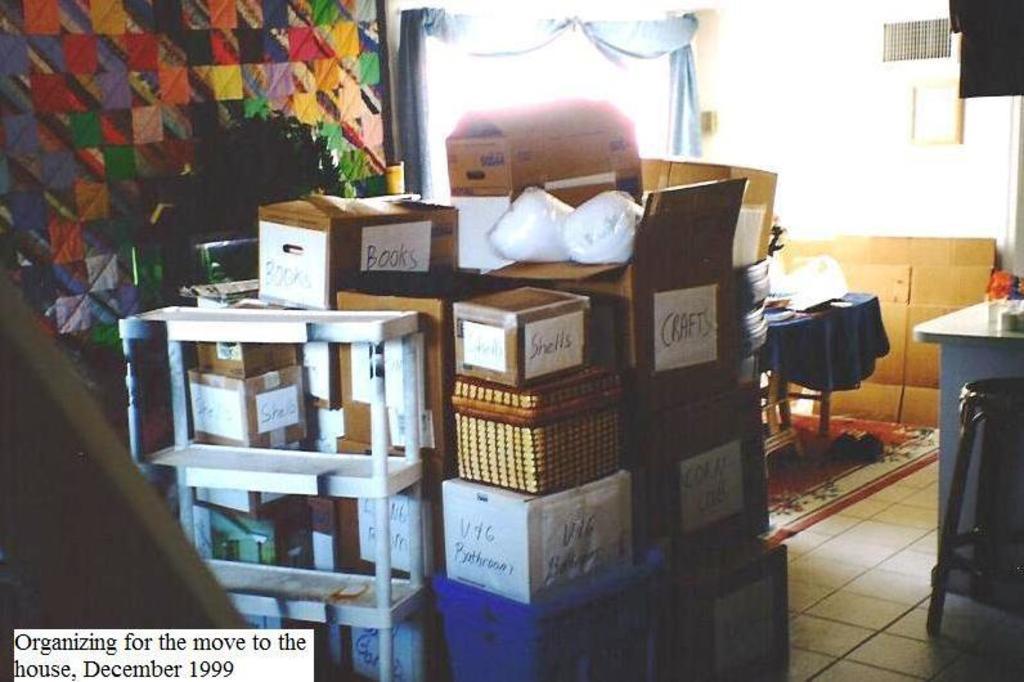Describe this image in one or two sentences. There are few boxes which has something written on it is placed beside a white stand and there are some other objects in the background. 